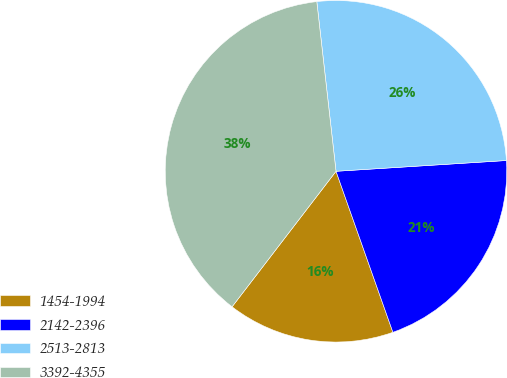Convert chart. <chart><loc_0><loc_0><loc_500><loc_500><pie_chart><fcel>1454-1994<fcel>2142-2396<fcel>2513-2813<fcel>3392-4355<nl><fcel>15.82%<fcel>20.6%<fcel>25.79%<fcel>37.79%<nl></chart> 